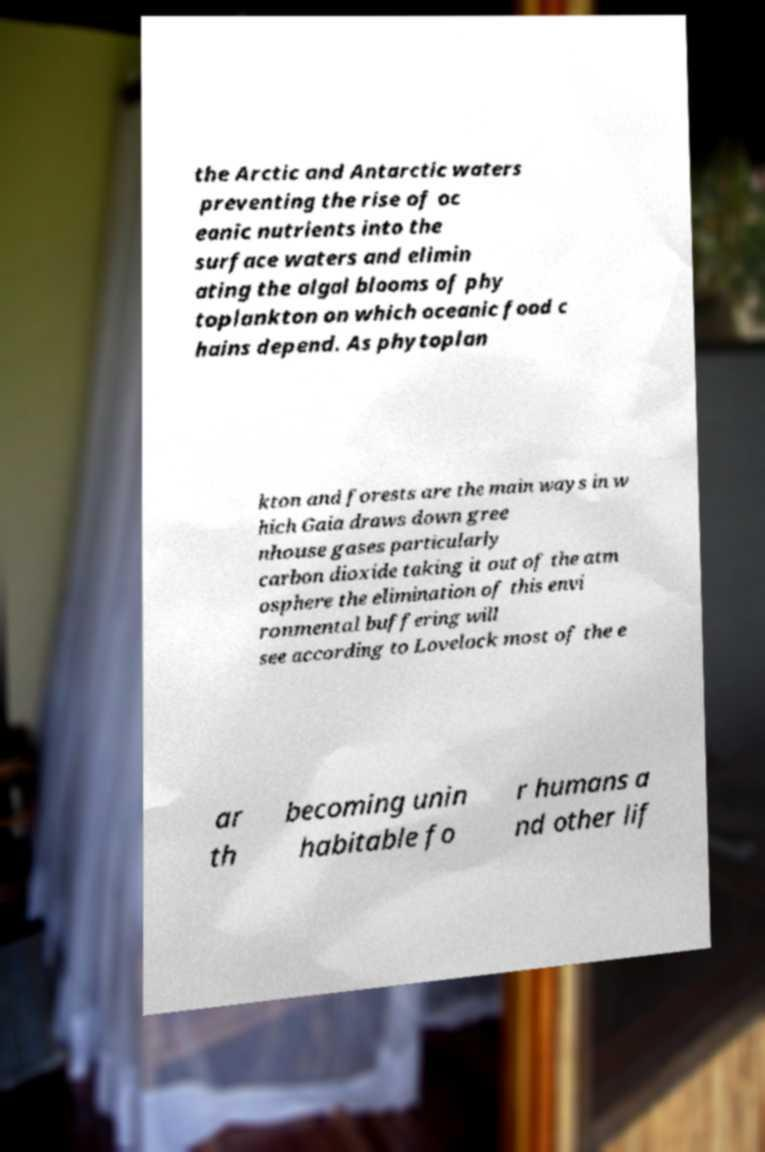Could you extract and type out the text from this image? the Arctic and Antarctic waters preventing the rise of oc eanic nutrients into the surface waters and elimin ating the algal blooms of phy toplankton on which oceanic food c hains depend. As phytoplan kton and forests are the main ways in w hich Gaia draws down gree nhouse gases particularly carbon dioxide taking it out of the atm osphere the elimination of this envi ronmental buffering will see according to Lovelock most of the e ar th becoming unin habitable fo r humans a nd other lif 